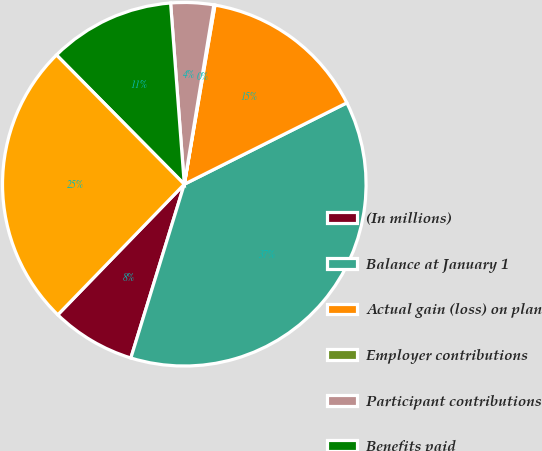Convert chart to OTSL. <chart><loc_0><loc_0><loc_500><loc_500><pie_chart><fcel>(In millions)<fcel>Balance at January 1<fcel>Actual gain (loss) on plan<fcel>Employer contributions<fcel>Participant contributions<fcel>Benefits paid<fcel>Balance at December 31<nl><fcel>7.5%<fcel>37.14%<fcel>14.91%<fcel>0.1%<fcel>3.8%<fcel>11.21%<fcel>25.34%<nl></chart> 